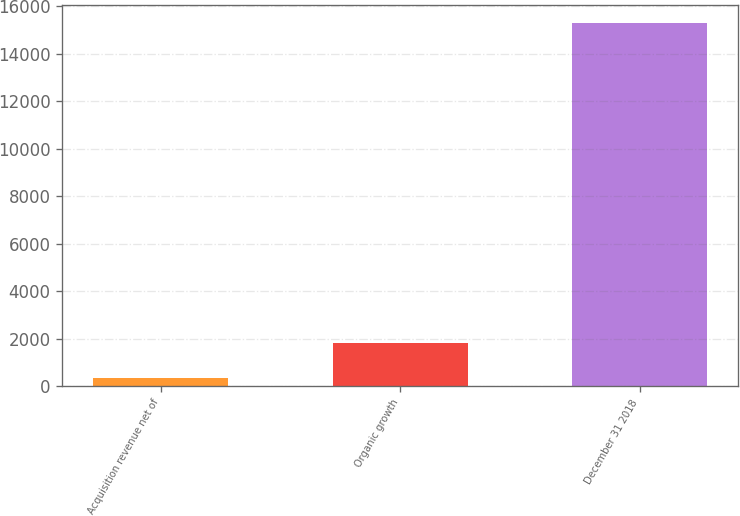Convert chart to OTSL. <chart><loc_0><loc_0><loc_500><loc_500><bar_chart><fcel>Acquisition revenue net of<fcel>Organic growth<fcel>December 31 2018<nl><fcel>326.6<fcel>1822.96<fcel>15290.2<nl></chart> 